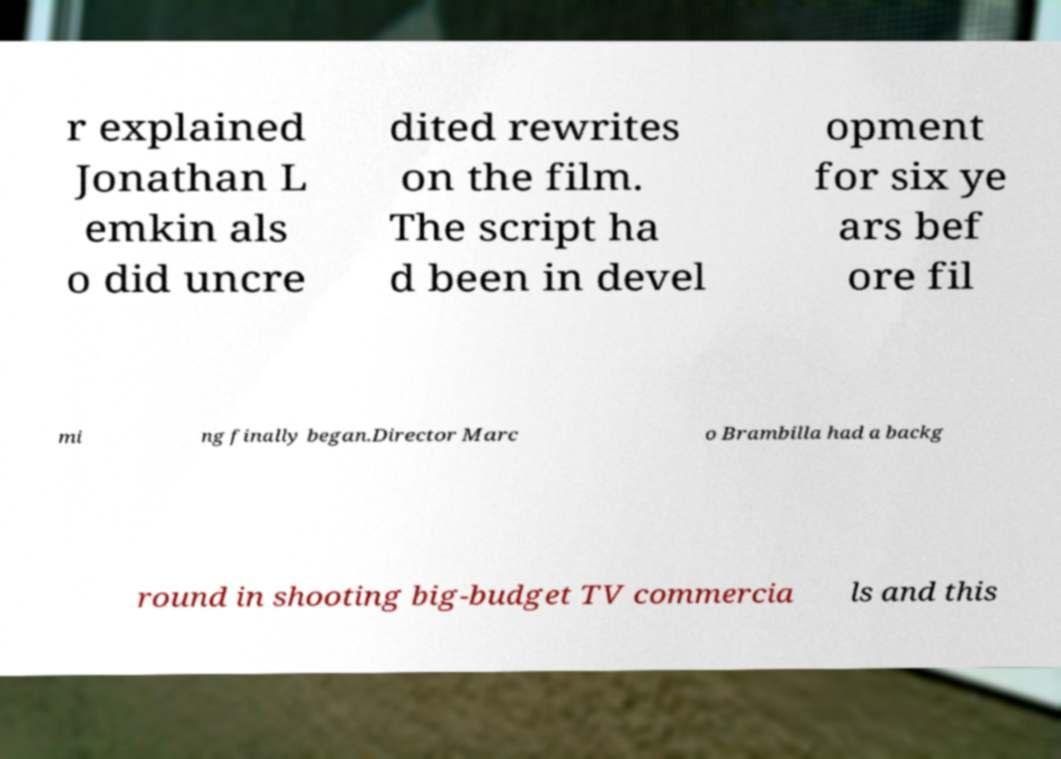For documentation purposes, I need the text within this image transcribed. Could you provide that? r explained Jonathan L emkin als o did uncre dited rewrites on the film. The script ha d been in devel opment for six ye ars bef ore fil mi ng finally began.Director Marc o Brambilla had a backg round in shooting big-budget TV commercia ls and this 